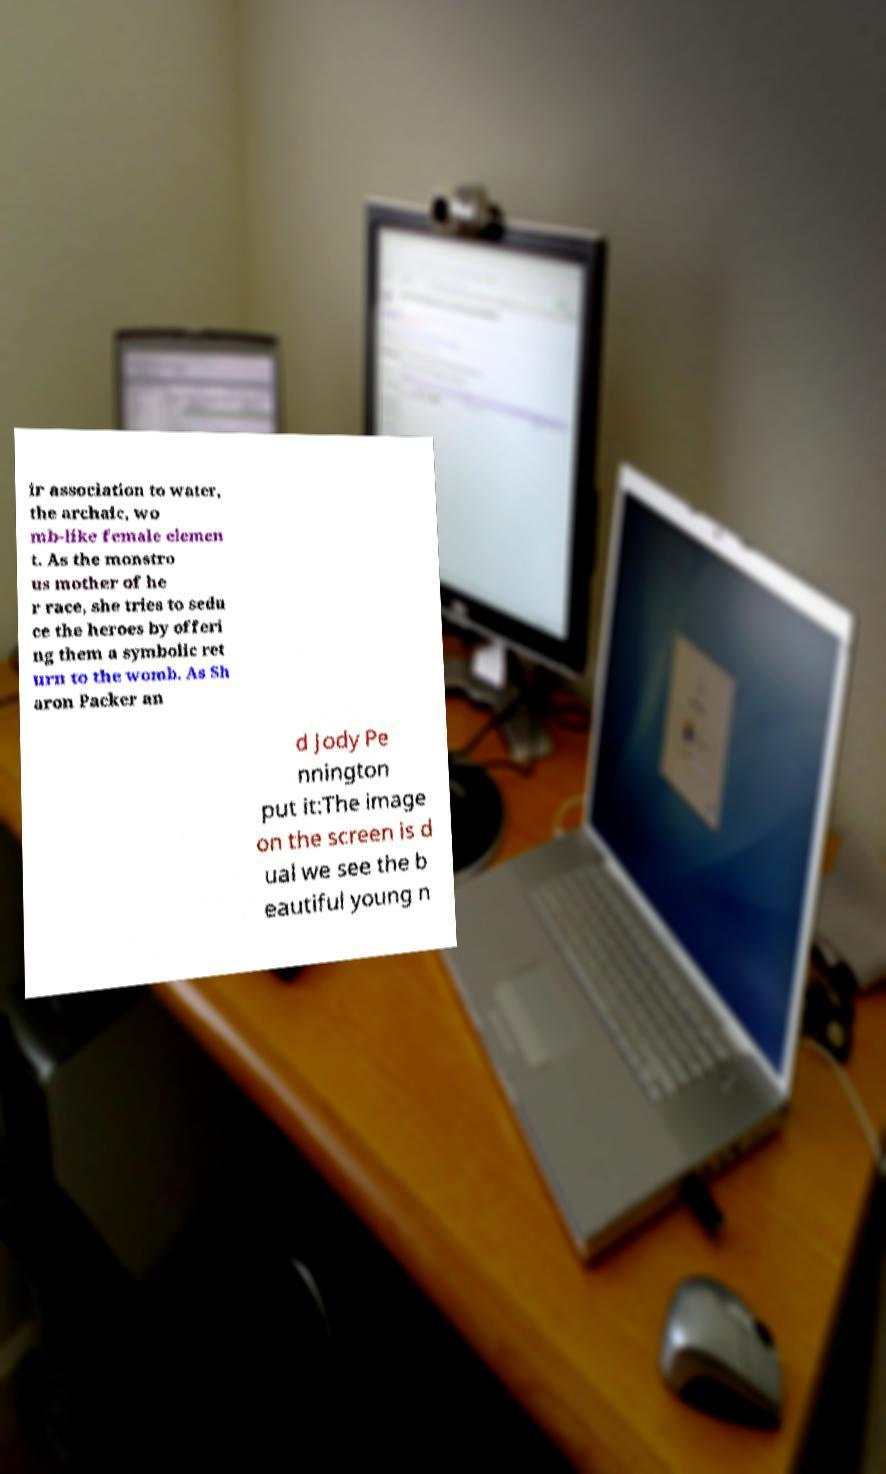What messages or text are displayed in this image? I need them in a readable, typed format. ir association to water, the archaic, wo mb-like female elemen t. As the monstro us mother of he r race, she tries to sedu ce the heroes by offeri ng them a symbolic ret urn to the womb. As Sh aron Packer an d Jody Pe nnington put it:The image on the screen is d ual we see the b eautiful young n 